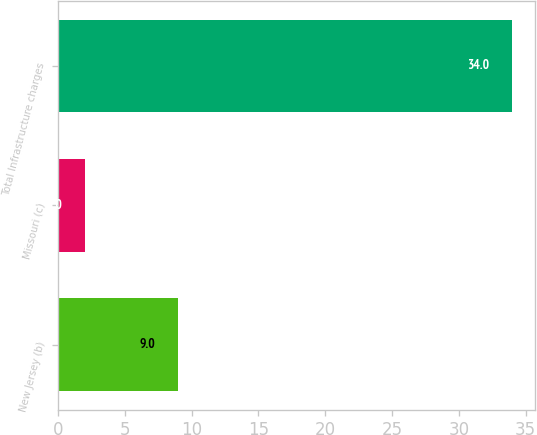Convert chart to OTSL. <chart><loc_0><loc_0><loc_500><loc_500><bar_chart><fcel>New Jersey (b)<fcel>Missouri (c)<fcel>Total Infrastructure charges<nl><fcel>9<fcel>2<fcel>34<nl></chart> 